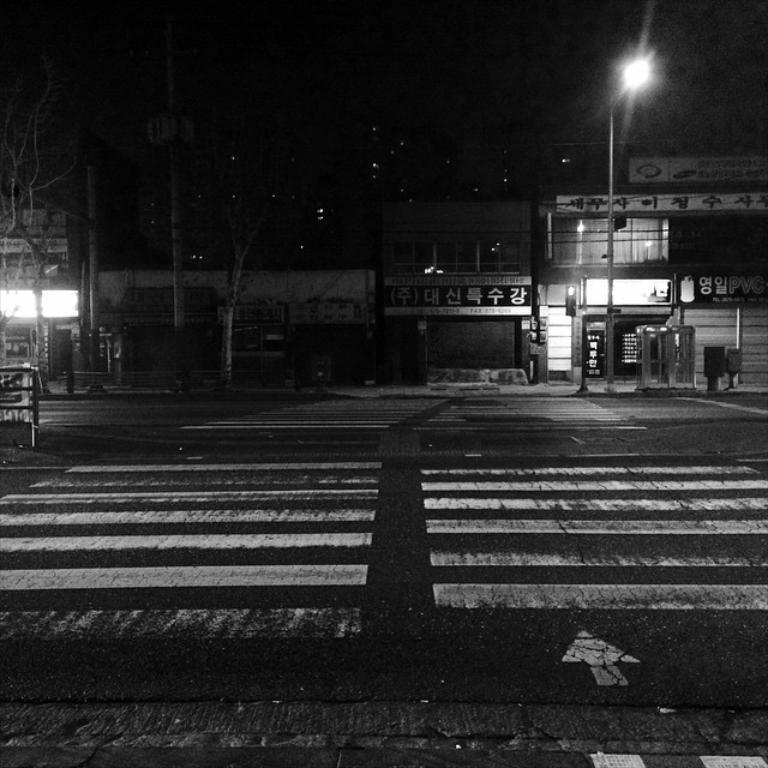Can you describe this image briefly? This is a black and white image. In this image we can see road, bins, stores, name boards, street poles, trees and a street light. 